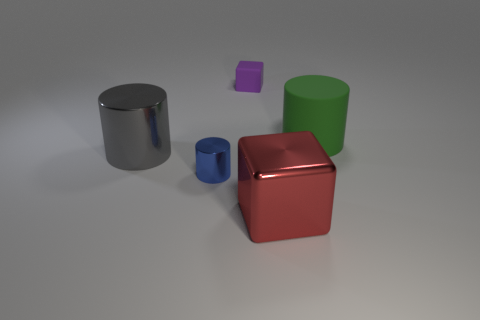Subtract all large matte cylinders. How many cylinders are left? 2 Subtract all cylinders. How many objects are left? 2 Add 2 small cyan cubes. How many objects exist? 7 Add 1 tiny purple rubber cubes. How many tiny purple rubber cubes are left? 2 Add 1 gray shiny cylinders. How many gray shiny cylinders exist? 2 Subtract 1 red blocks. How many objects are left? 4 Subtract all blue metallic cylinders. Subtract all tiny rubber cubes. How many objects are left? 3 